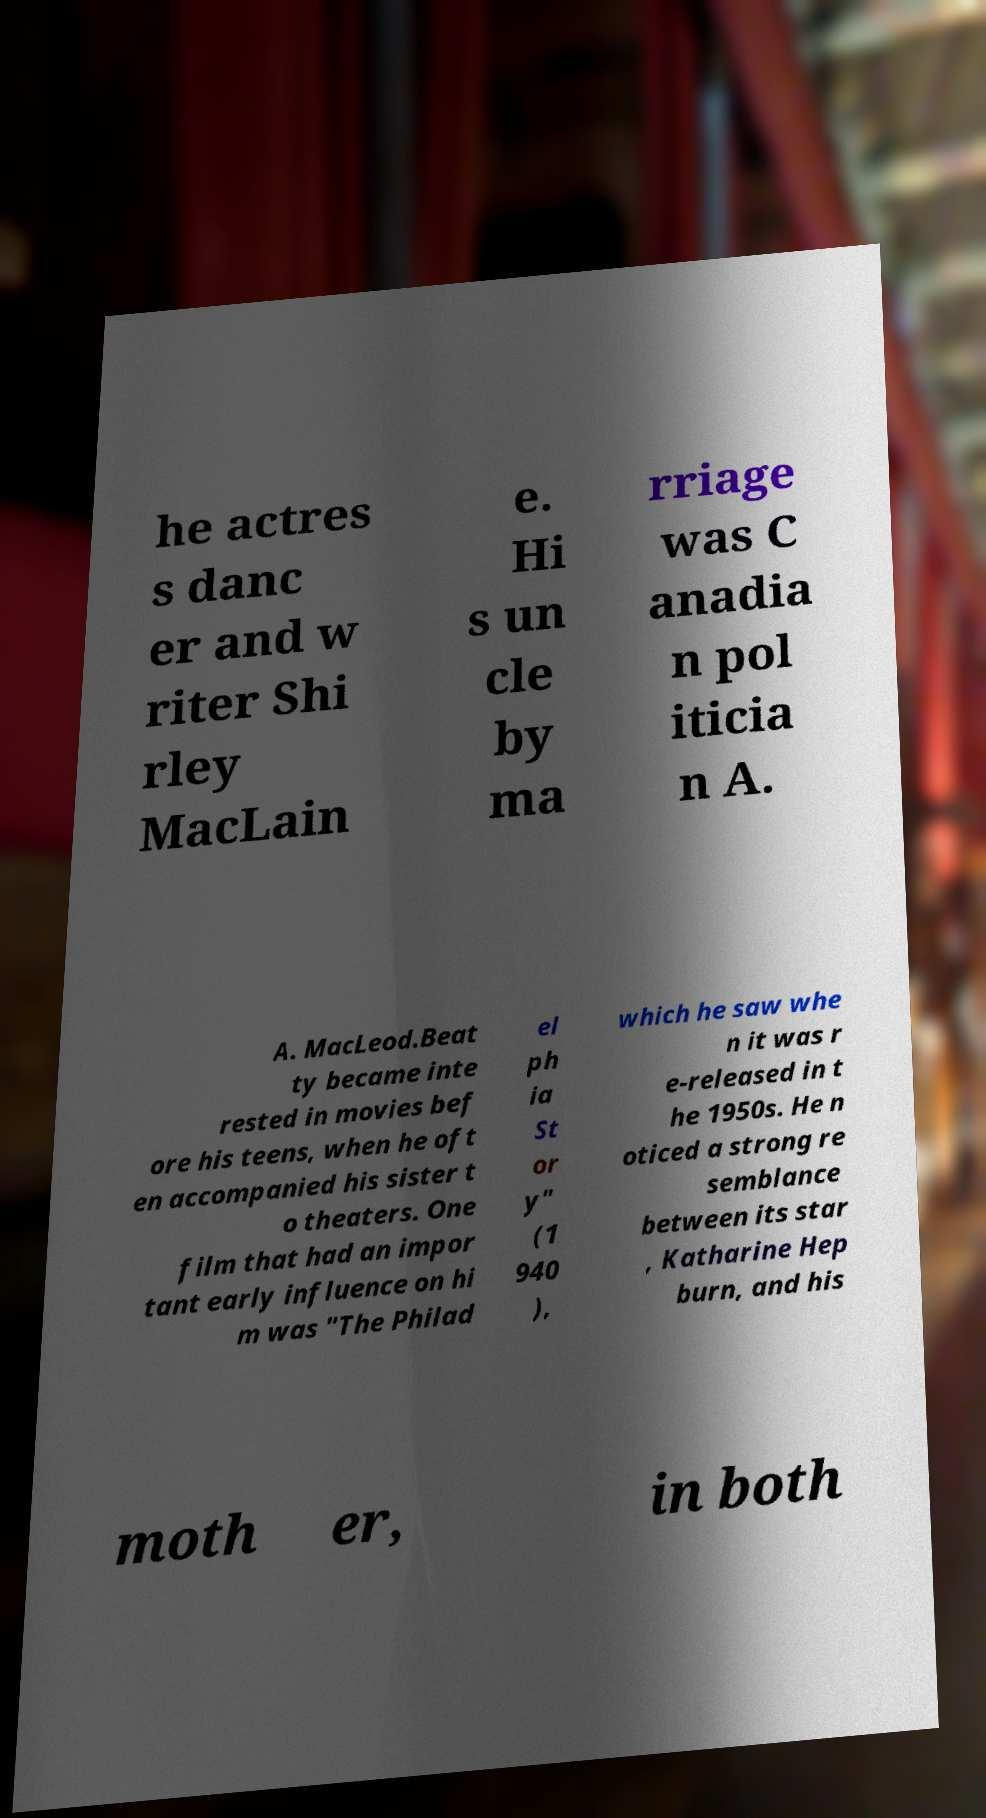Could you extract and type out the text from this image? he actres s danc er and w riter Shi rley MacLain e. Hi s un cle by ma rriage was C anadia n pol iticia n A. A. MacLeod.Beat ty became inte rested in movies bef ore his teens, when he oft en accompanied his sister t o theaters. One film that had an impor tant early influence on hi m was "The Philad el ph ia St or y" (1 940 ), which he saw whe n it was r e-released in t he 1950s. He n oticed a strong re semblance between its star , Katharine Hep burn, and his moth er, in both 